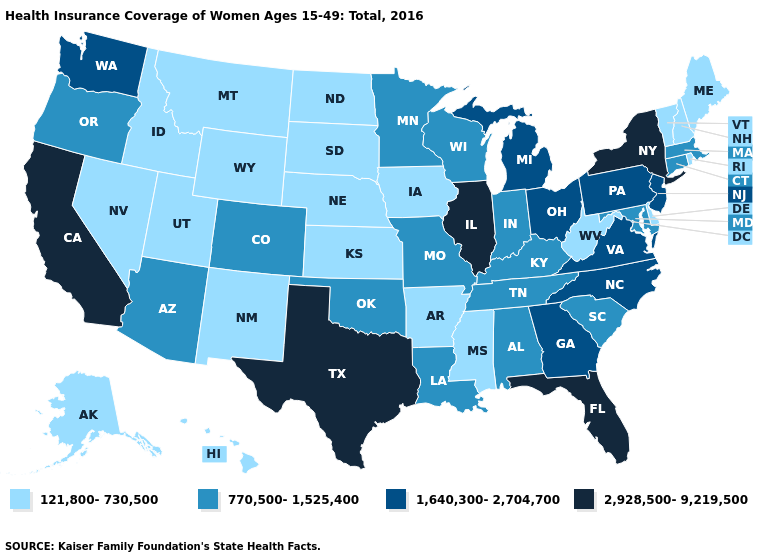What is the value of Minnesota?
Keep it brief. 770,500-1,525,400. What is the value of Virginia?
Write a very short answer. 1,640,300-2,704,700. Which states have the lowest value in the West?
Give a very brief answer. Alaska, Hawaii, Idaho, Montana, Nevada, New Mexico, Utah, Wyoming. What is the value of New Jersey?
Give a very brief answer. 1,640,300-2,704,700. Name the states that have a value in the range 1,640,300-2,704,700?
Concise answer only. Georgia, Michigan, New Jersey, North Carolina, Ohio, Pennsylvania, Virginia, Washington. What is the value of Hawaii?
Quick response, please. 121,800-730,500. Name the states that have a value in the range 2,928,500-9,219,500?
Be succinct. California, Florida, Illinois, New York, Texas. Does Indiana have the lowest value in the MidWest?
Be succinct. No. What is the highest value in the USA?
Short answer required. 2,928,500-9,219,500. Does the first symbol in the legend represent the smallest category?
Short answer required. Yes. What is the value of Utah?
Quick response, please. 121,800-730,500. What is the value of South Carolina?
Concise answer only. 770,500-1,525,400. Does Illinois have the same value as Oklahoma?
Quick response, please. No. Which states have the lowest value in the USA?
Quick response, please. Alaska, Arkansas, Delaware, Hawaii, Idaho, Iowa, Kansas, Maine, Mississippi, Montana, Nebraska, Nevada, New Hampshire, New Mexico, North Dakota, Rhode Island, South Dakota, Utah, Vermont, West Virginia, Wyoming. 